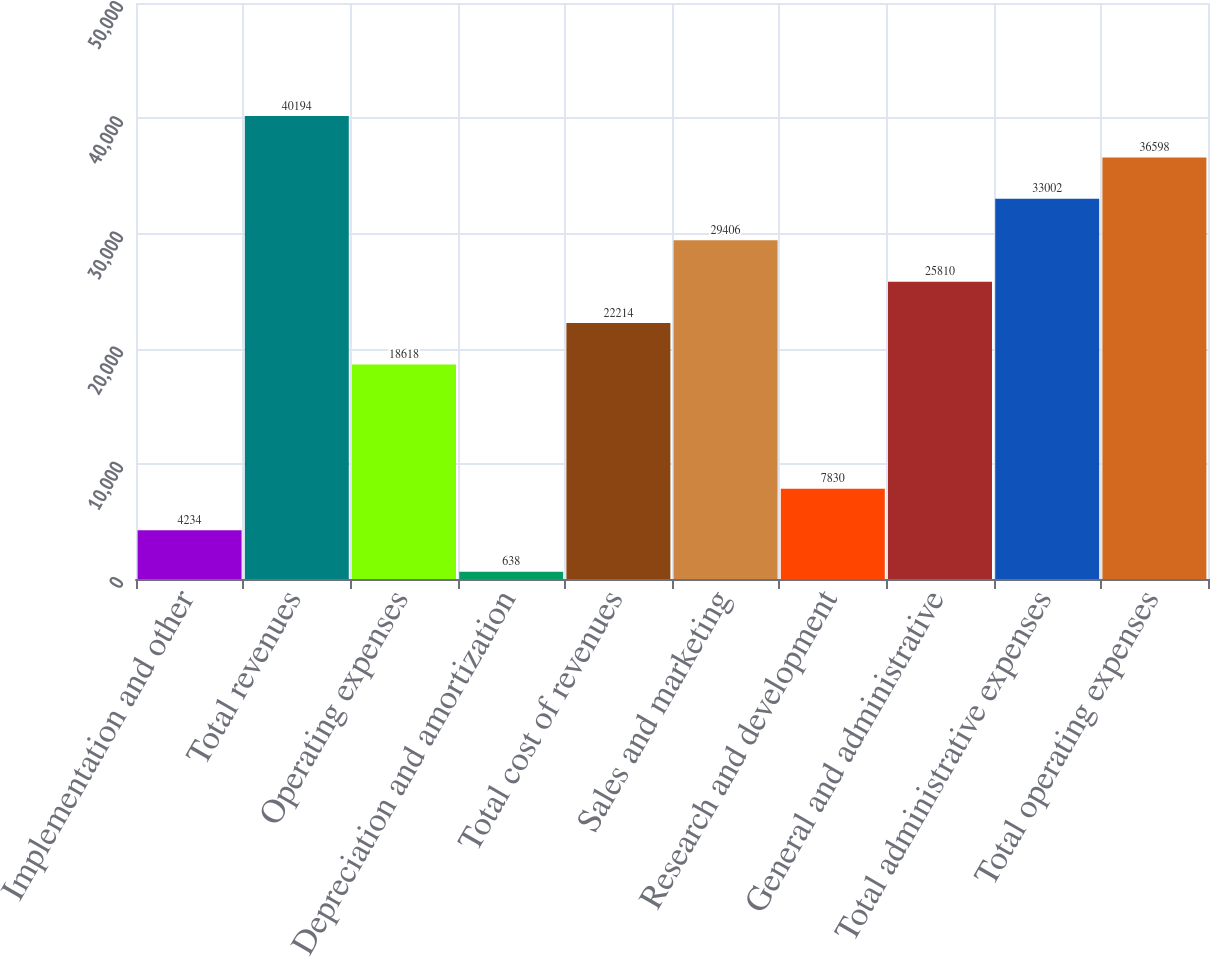Convert chart to OTSL. <chart><loc_0><loc_0><loc_500><loc_500><bar_chart><fcel>Implementation and other<fcel>Total revenues<fcel>Operating expenses<fcel>Depreciation and amortization<fcel>Total cost of revenues<fcel>Sales and marketing<fcel>Research and development<fcel>General and administrative<fcel>Total administrative expenses<fcel>Total operating expenses<nl><fcel>4234<fcel>40194<fcel>18618<fcel>638<fcel>22214<fcel>29406<fcel>7830<fcel>25810<fcel>33002<fcel>36598<nl></chart> 